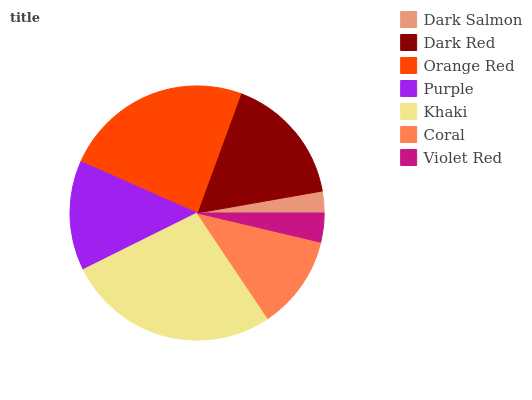Is Dark Salmon the minimum?
Answer yes or no. Yes. Is Khaki the maximum?
Answer yes or no. Yes. Is Dark Red the minimum?
Answer yes or no. No. Is Dark Red the maximum?
Answer yes or no. No. Is Dark Red greater than Dark Salmon?
Answer yes or no. Yes. Is Dark Salmon less than Dark Red?
Answer yes or no. Yes. Is Dark Salmon greater than Dark Red?
Answer yes or no. No. Is Dark Red less than Dark Salmon?
Answer yes or no. No. Is Purple the high median?
Answer yes or no. Yes. Is Purple the low median?
Answer yes or no. Yes. Is Dark Red the high median?
Answer yes or no. No. Is Dark Red the low median?
Answer yes or no. No. 